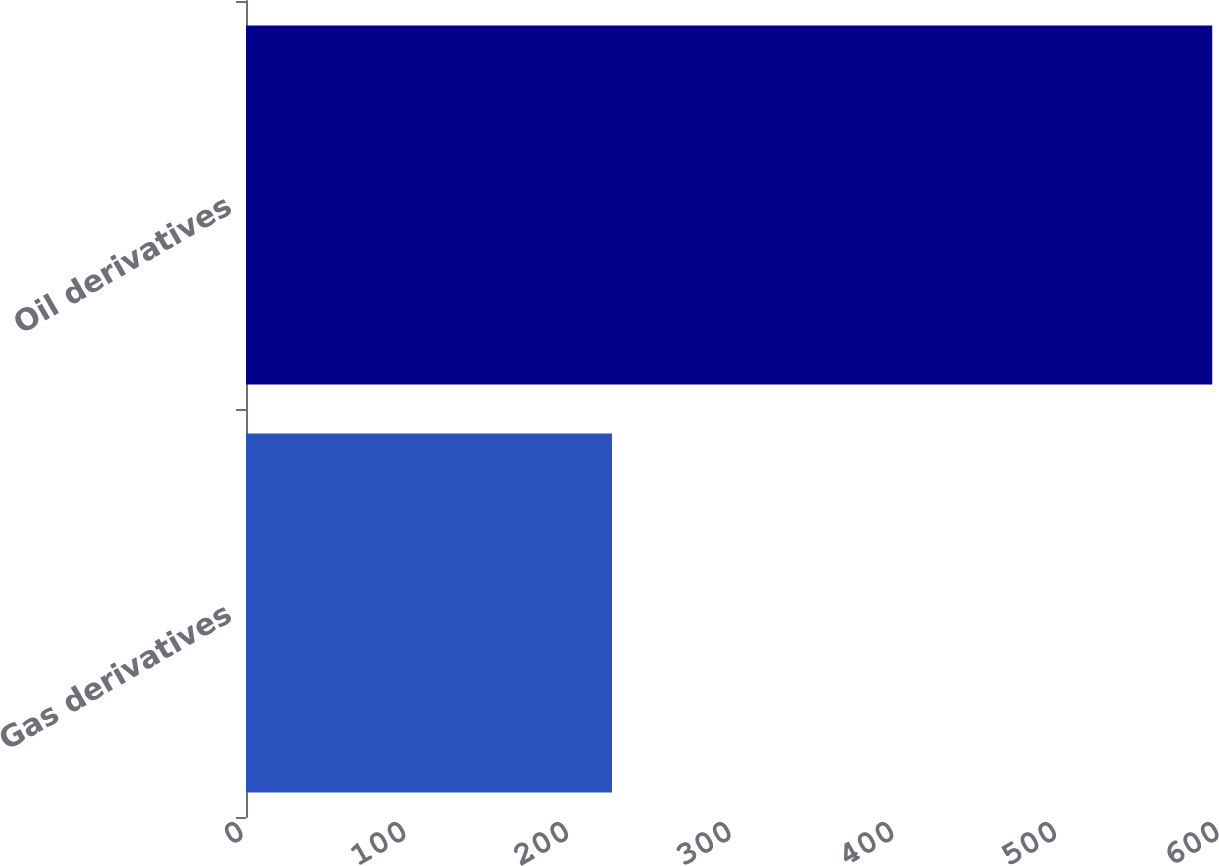Convert chart to OTSL. <chart><loc_0><loc_0><loc_500><loc_500><bar_chart><fcel>Gas derivatives<fcel>Oil derivatives<nl><fcel>225<fcel>594<nl></chart> 